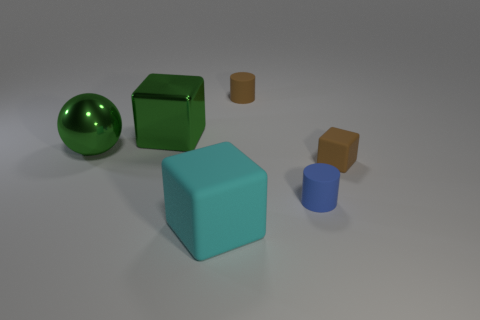Add 3 large cyan matte cylinders. How many objects exist? 9 Subtract all balls. How many objects are left? 5 Add 4 large purple cylinders. How many large purple cylinders exist? 4 Subtract 0 yellow spheres. How many objects are left? 6 Subtract all cylinders. Subtract all large green things. How many objects are left? 2 Add 4 big metallic blocks. How many big metallic blocks are left? 5 